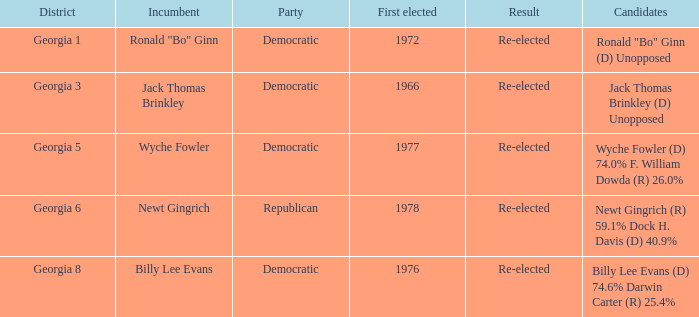1% dock h. davis (d) 4 Republican. 